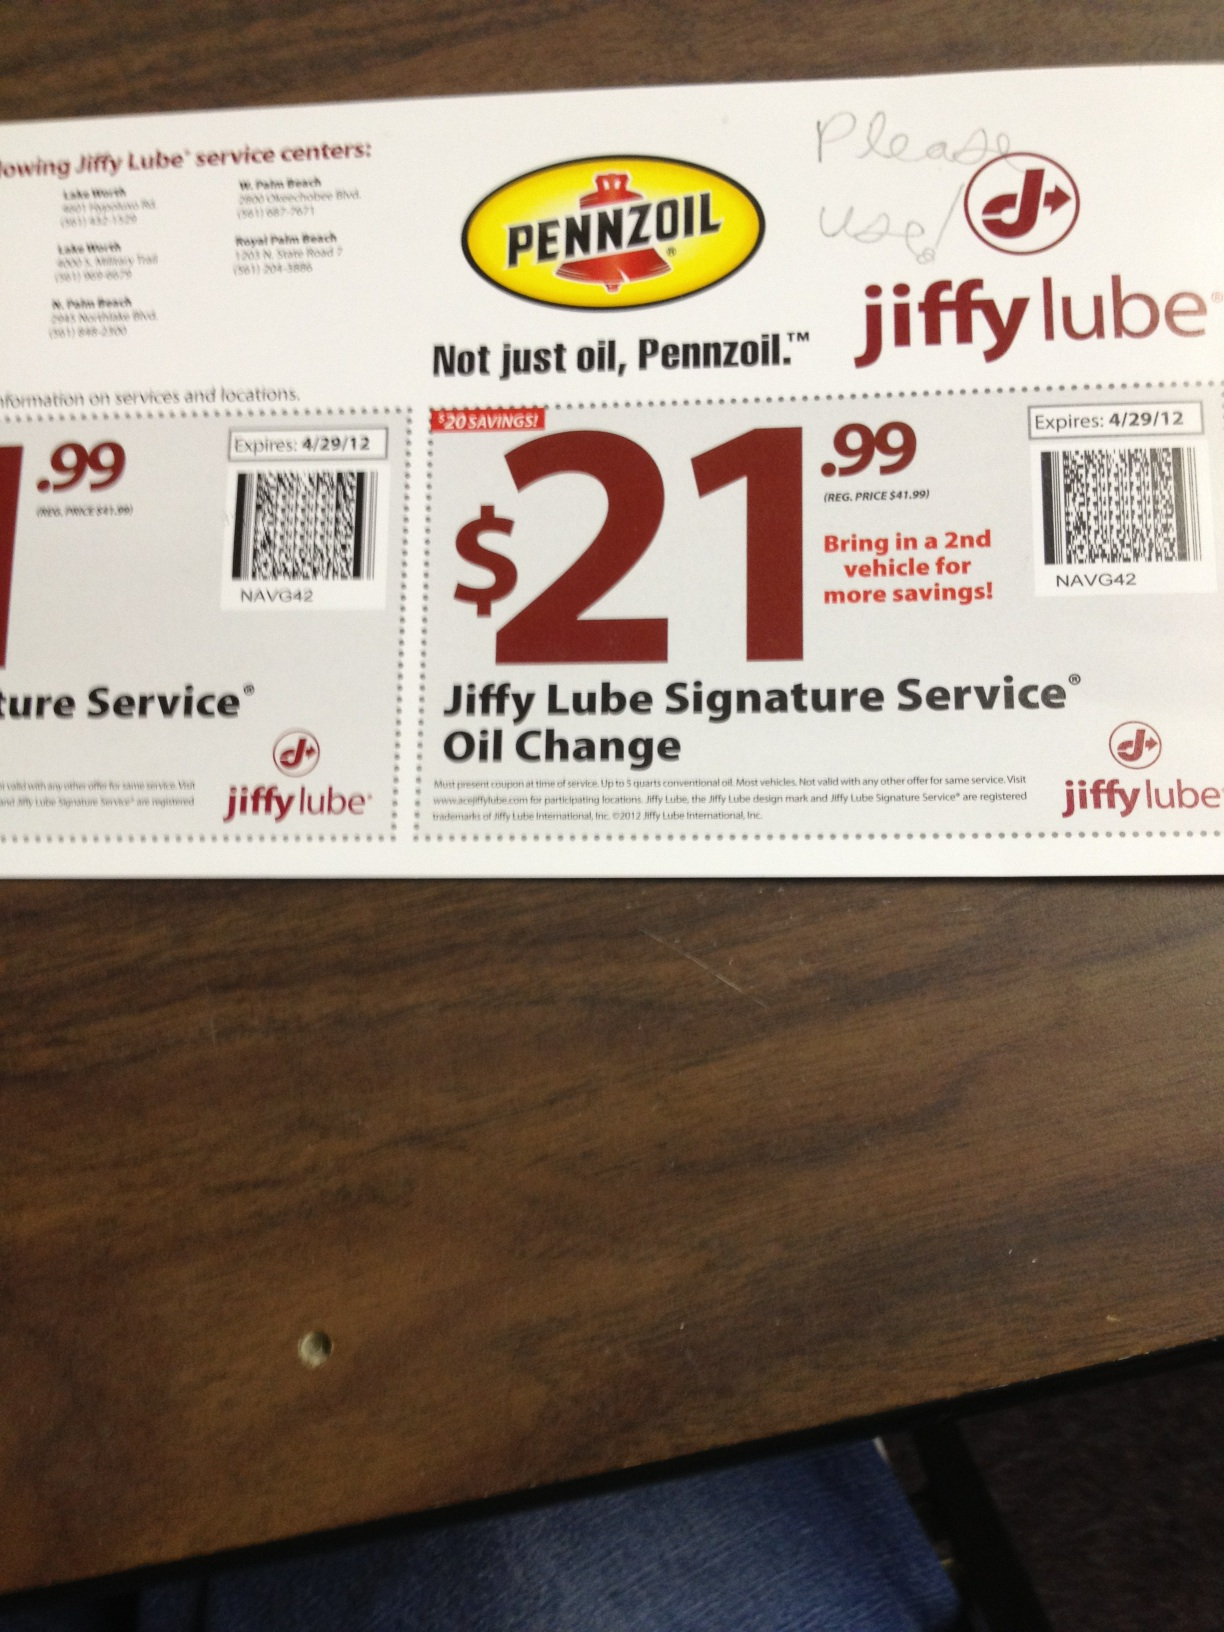What brand of oil is featured on this coupon? The coupon features Pennzoil as the brand of oil. 